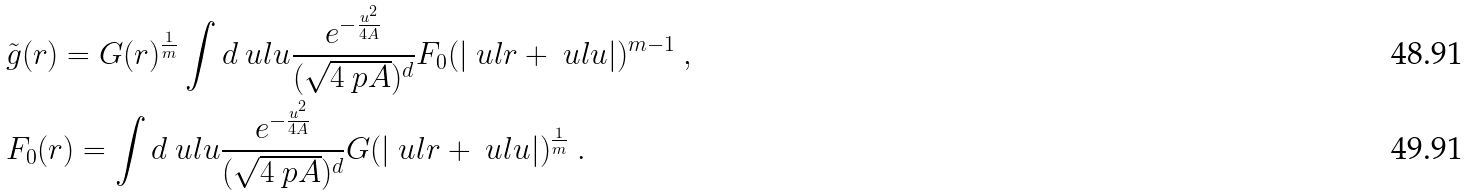<formula> <loc_0><loc_0><loc_500><loc_500>& \tilde { g } ( r ) = G ( r ) ^ { \frac { 1 } { m } } \int d \ u l u \frac { e ^ { - \frac { u ^ { 2 } } { 4 A } } } { ( \sqrt { 4 \ p A } ) ^ { d } } F _ { 0 } ( | \ u l r + \ u l u | ) ^ { m - 1 } \ , \\ & F _ { 0 } ( r ) = \int d \ u l u \frac { e ^ { - \frac { u ^ { 2 } } { 4 A } } } { ( \sqrt { 4 \ p A } ) ^ { d } } G ( | \ u l r + \ u l u | ) ^ { \frac { 1 } { m } } \ .</formula> 